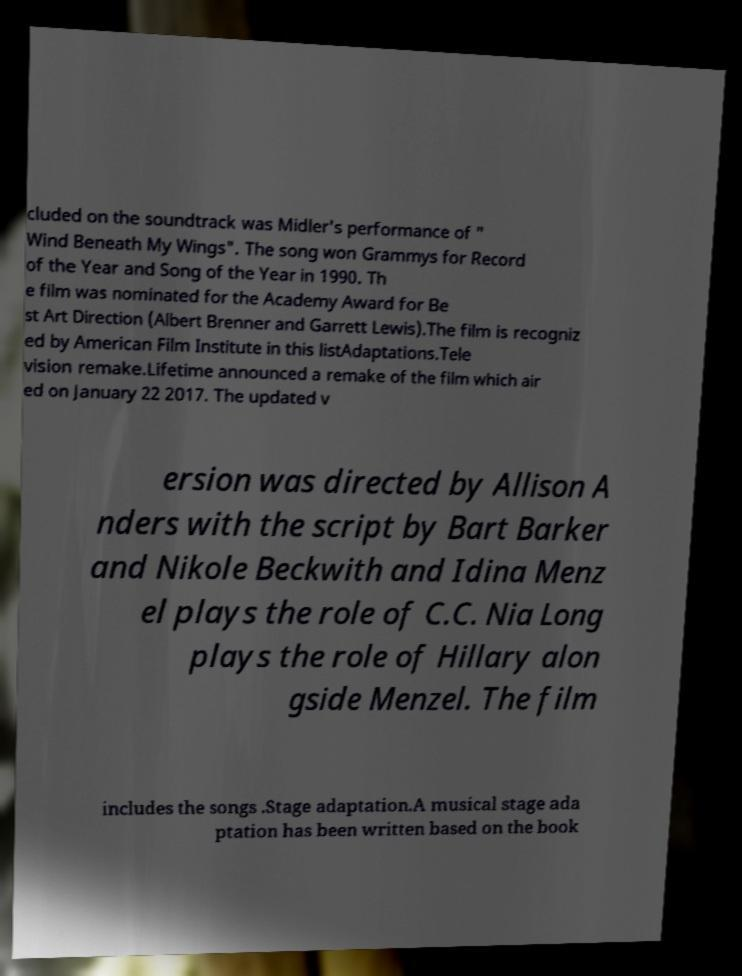Please identify and transcribe the text found in this image. cluded on the soundtrack was Midler's performance of " Wind Beneath My Wings". The song won Grammys for Record of the Year and Song of the Year in 1990. Th e film was nominated for the Academy Award for Be st Art Direction (Albert Brenner and Garrett Lewis).The film is recogniz ed by American Film Institute in this listAdaptations.Tele vision remake.Lifetime announced a remake of the film which air ed on January 22 2017. The updated v ersion was directed by Allison A nders with the script by Bart Barker and Nikole Beckwith and Idina Menz el plays the role of C.C. Nia Long plays the role of Hillary alon gside Menzel. The film includes the songs .Stage adaptation.A musical stage ada ptation has been written based on the book 